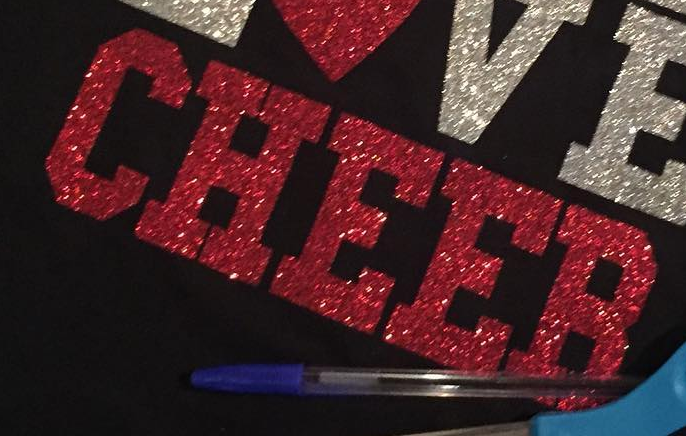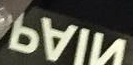Read the text content from these images in order, separated by a semicolon. CHEER; NIAP 